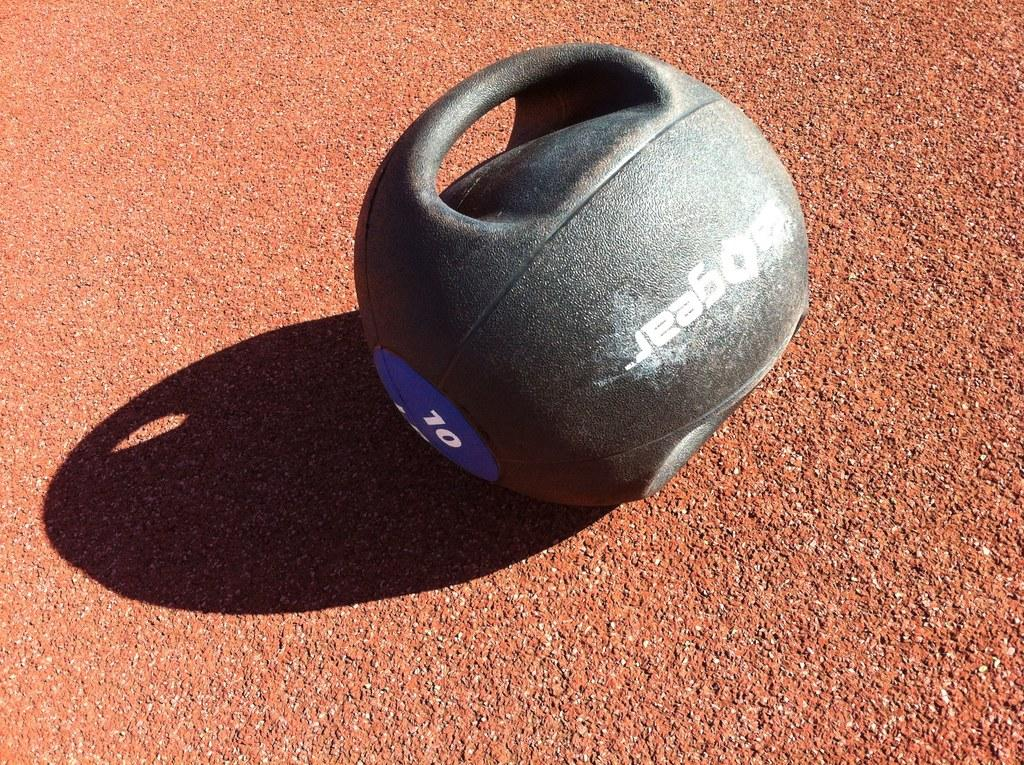What object is present in the image? There is a ball in the image. What can be seen on the surface of the ball? The ball has text and numbers written on it. Where is the ball located in the image? The ball is on a surface. What is the color of the surface the ball is on? The surface is brown in color. Which direction is the ball facing in the image? The provided facts do not mention the direction the ball is facing, so it cannot be determined from the image. 